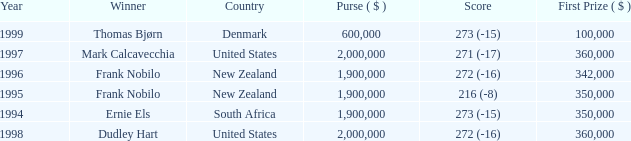Parse the table in full. {'header': ['Year', 'Winner', 'Country', 'Purse ( $ )', 'Score', 'First Prize ( $ )'], 'rows': [['1999', 'Thomas Bjørn', 'Denmark', '600,000', '273 (-15)', '100,000'], ['1997', 'Mark Calcavecchia', 'United States', '2,000,000', '271 (-17)', '360,000'], ['1996', 'Frank Nobilo', 'New Zealand', '1,900,000', '272 (-16)', '342,000'], ['1995', 'Frank Nobilo', 'New Zealand', '1,900,000', '216 (-8)', '350,000'], ['1994', 'Ernie Els', 'South Africa', '1,900,000', '273 (-15)', '350,000'], ['1998', 'Dudley Hart', 'United States', '2,000,000', '272 (-16)', '360,000']]} What was the top first place prize in 1997? 360000.0. 